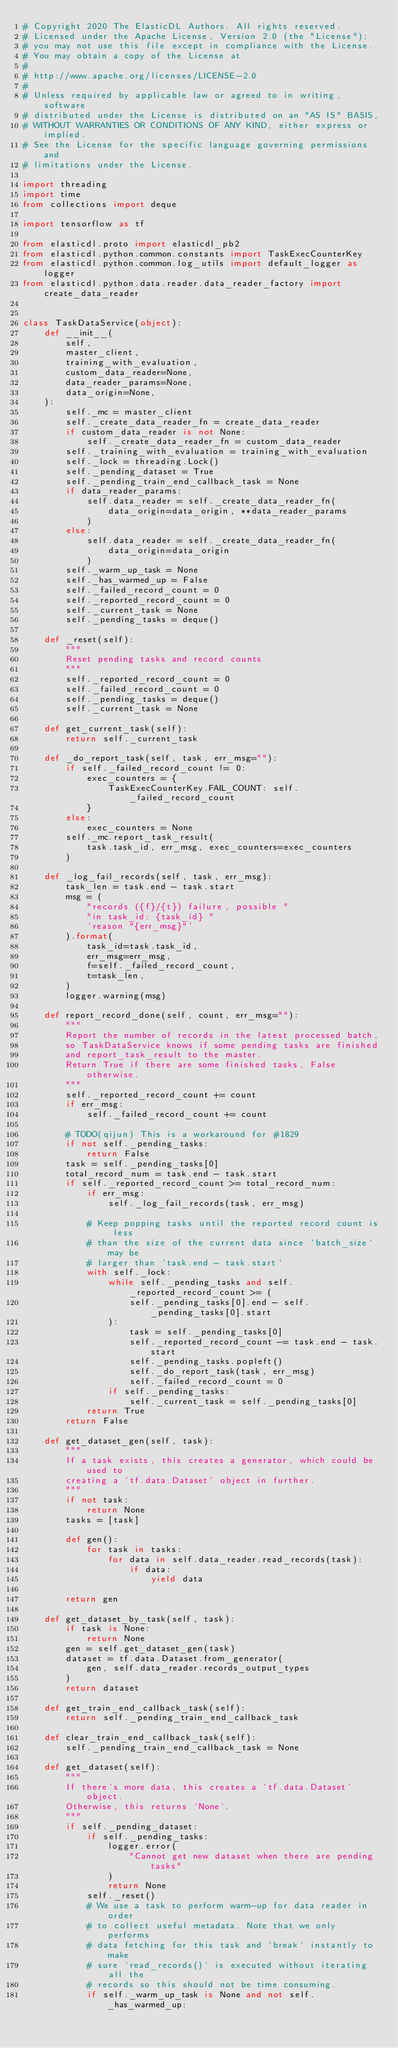<code> <loc_0><loc_0><loc_500><loc_500><_Python_># Copyright 2020 The ElasticDL Authors. All rights reserved.
# Licensed under the Apache License, Version 2.0 (the "License");
# you may not use this file except in compliance with the License.
# You may obtain a copy of the License at
#
# http://www.apache.org/licenses/LICENSE-2.0
#
# Unless required by applicable law or agreed to in writing, software
# distributed under the License is distributed on an "AS IS" BASIS,
# WITHOUT WARRANTIES OR CONDITIONS OF ANY KIND, either express or implied.
# See the License for the specific language governing permissions and
# limitations under the License.

import threading
import time
from collections import deque

import tensorflow as tf

from elasticdl.proto import elasticdl_pb2
from elasticdl.python.common.constants import TaskExecCounterKey
from elasticdl.python.common.log_utils import default_logger as logger
from elasticdl.python.data.reader.data_reader_factory import create_data_reader


class TaskDataService(object):
    def __init__(
        self,
        master_client,
        training_with_evaluation,
        custom_data_reader=None,
        data_reader_params=None,
        data_origin=None,
    ):
        self._mc = master_client
        self._create_data_reader_fn = create_data_reader
        if custom_data_reader is not None:
            self._create_data_reader_fn = custom_data_reader
        self._training_with_evaluation = training_with_evaluation
        self._lock = threading.Lock()
        self._pending_dataset = True
        self._pending_train_end_callback_task = None
        if data_reader_params:
            self.data_reader = self._create_data_reader_fn(
                data_origin=data_origin, **data_reader_params
            )
        else:
            self.data_reader = self._create_data_reader_fn(
                data_origin=data_origin
            )
        self._warm_up_task = None
        self._has_warmed_up = False
        self._failed_record_count = 0
        self._reported_record_count = 0
        self._current_task = None
        self._pending_tasks = deque()

    def _reset(self):
        """
        Reset pending tasks and record counts
        """
        self._reported_record_count = 0
        self._failed_record_count = 0
        self._pending_tasks = deque()
        self._current_task = None

    def get_current_task(self):
        return self._current_task

    def _do_report_task(self, task, err_msg=""):
        if self._failed_record_count != 0:
            exec_counters = {
                TaskExecCounterKey.FAIL_COUNT: self._failed_record_count
            }
        else:
            exec_counters = None
        self._mc.report_task_result(
            task.task_id, err_msg, exec_counters=exec_counters
        )

    def _log_fail_records(self, task, err_msg):
        task_len = task.end - task.start
        msg = (
            "records ({f}/{t}) failure, possible "
            "in task_id: {task_id} "
            'reason "{err_msg}"'
        ).format(
            task_id=task.task_id,
            err_msg=err_msg,
            f=self._failed_record_count,
            t=task_len,
        )
        logger.warning(msg)

    def report_record_done(self, count, err_msg=""):
        """
        Report the number of records in the latest processed batch,
        so TaskDataService knows if some pending tasks are finished
        and report_task_result to the master.
        Return True if there are some finished tasks, False otherwise.
        """
        self._reported_record_count += count
        if err_msg:
            self._failed_record_count += count

        # TODO(qijun) This is a workaround for #1829
        if not self._pending_tasks:
            return False
        task = self._pending_tasks[0]
        total_record_num = task.end - task.start
        if self._reported_record_count >= total_record_num:
            if err_msg:
                self._log_fail_records(task, err_msg)

            # Keep popping tasks until the reported record count is less
            # than the size of the current data since `batch_size` may be
            # larger than `task.end - task.start`
            with self._lock:
                while self._pending_tasks and self._reported_record_count >= (
                    self._pending_tasks[0].end - self._pending_tasks[0].start
                ):
                    task = self._pending_tasks[0]
                    self._reported_record_count -= task.end - task.start
                    self._pending_tasks.popleft()
                    self._do_report_task(task, err_msg)
                    self._failed_record_count = 0
                if self._pending_tasks:
                    self._current_task = self._pending_tasks[0]
            return True
        return False

    def get_dataset_gen(self, task):
        """
        If a task exists, this creates a generator, which could be used to
        creating a `tf.data.Dataset` object in further.
        """
        if not task:
            return None
        tasks = [task]

        def gen():
            for task in tasks:
                for data in self.data_reader.read_records(task):
                    if data:
                        yield data

        return gen

    def get_dataset_by_task(self, task):
        if task is None:
            return None
        gen = self.get_dataset_gen(task)
        dataset = tf.data.Dataset.from_generator(
            gen, self.data_reader.records_output_types
        )
        return dataset

    def get_train_end_callback_task(self):
        return self._pending_train_end_callback_task

    def clear_train_end_callback_task(self):
        self._pending_train_end_callback_task = None

    def get_dataset(self):
        """
        If there's more data, this creates a `tf.data.Dataset` object.
        Otherwise, this returns `None`.
        """
        if self._pending_dataset:
            if self._pending_tasks:
                logger.error(
                    "Cannot get new dataset when there are pending tasks"
                )
                return None
            self._reset()
            # We use a task to perform warm-up for data reader in order
            # to collect useful metadata. Note that we only performs
            # data fetching for this task and `break` instantly to make
            # sure `read_records()` is executed without iterating all the
            # records so this should not be time consuming.
            if self._warm_up_task is None and not self._has_warmed_up:</code> 